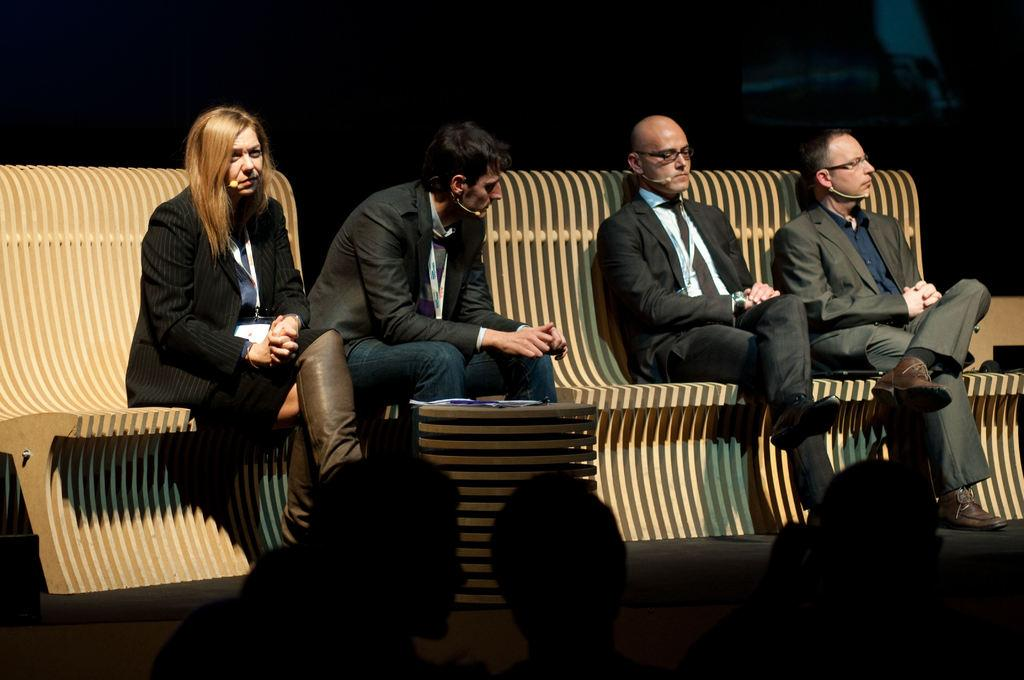How many people are in the image? There are four persons in the image. What are the persons doing in the image? The persons are sitting on benches. Is there any furniture present in the image? Yes, there is a table in the image. What role do the persons play in the image? The persons are considered an audience. What type of guitar is being played by the person in the image? There is no guitar present in the image; the persons are sitting on benches and are considered an audience. Can you describe the engine that is visible in the image? There is no engine present in the image. 